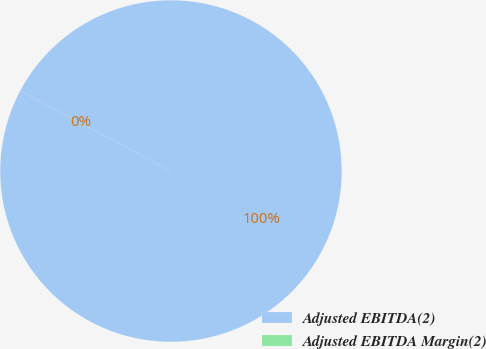<chart> <loc_0><loc_0><loc_500><loc_500><pie_chart><fcel>Adjusted EBITDA(2)<fcel>Adjusted EBITDA Margin(2)<nl><fcel>100.0%<fcel>0.0%<nl></chart> 